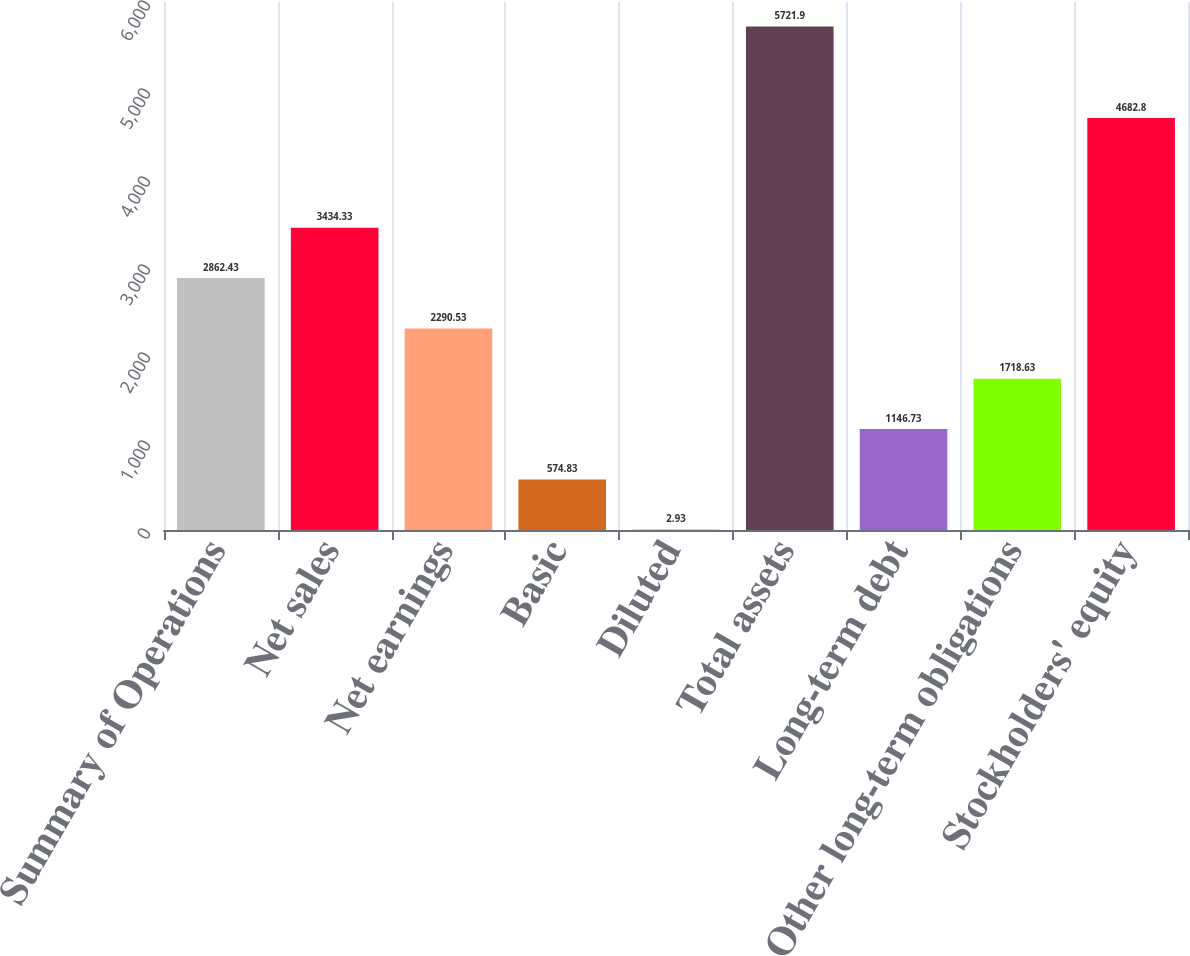<chart> <loc_0><loc_0><loc_500><loc_500><bar_chart><fcel>Summary of Operations<fcel>Net sales<fcel>Net earnings<fcel>Basic<fcel>Diluted<fcel>Total assets<fcel>Long-term debt<fcel>Other long-term obligations<fcel>Stockholders' equity<nl><fcel>2862.43<fcel>3434.33<fcel>2290.53<fcel>574.83<fcel>2.93<fcel>5721.9<fcel>1146.73<fcel>1718.63<fcel>4682.8<nl></chart> 